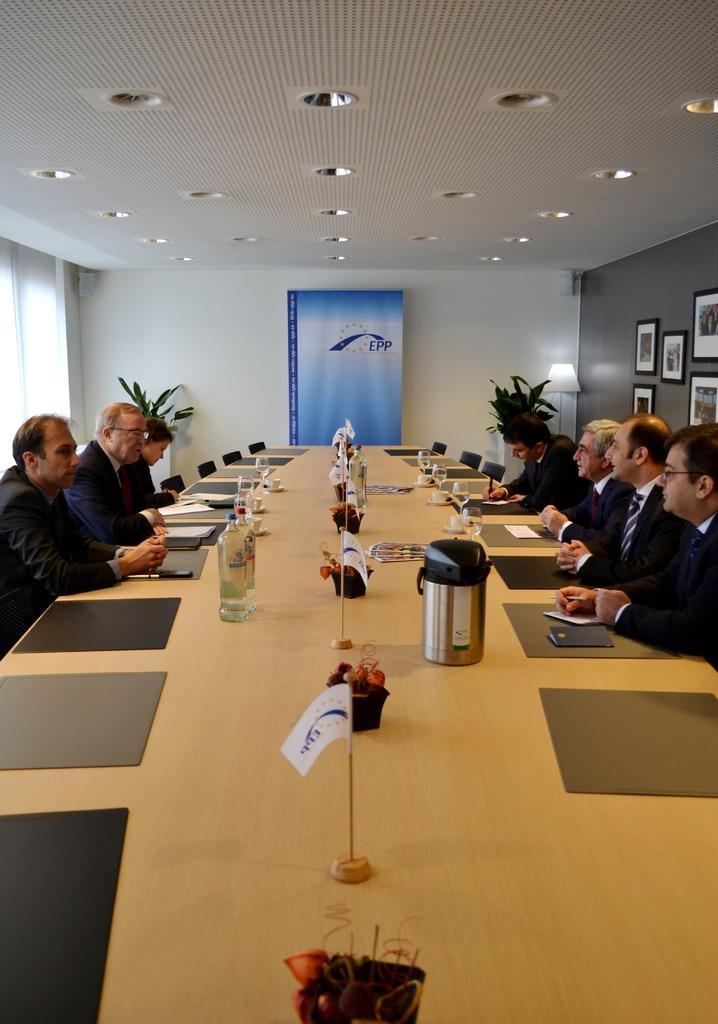Could you give a brief overview of what you see in this image? This picture shows few people seated and we see photo frames on the wall and couple of plants and we see glasses with water and flags and papers on the table and we see lights to the roof and stand light on the corner of the room and we see a hoarding. 